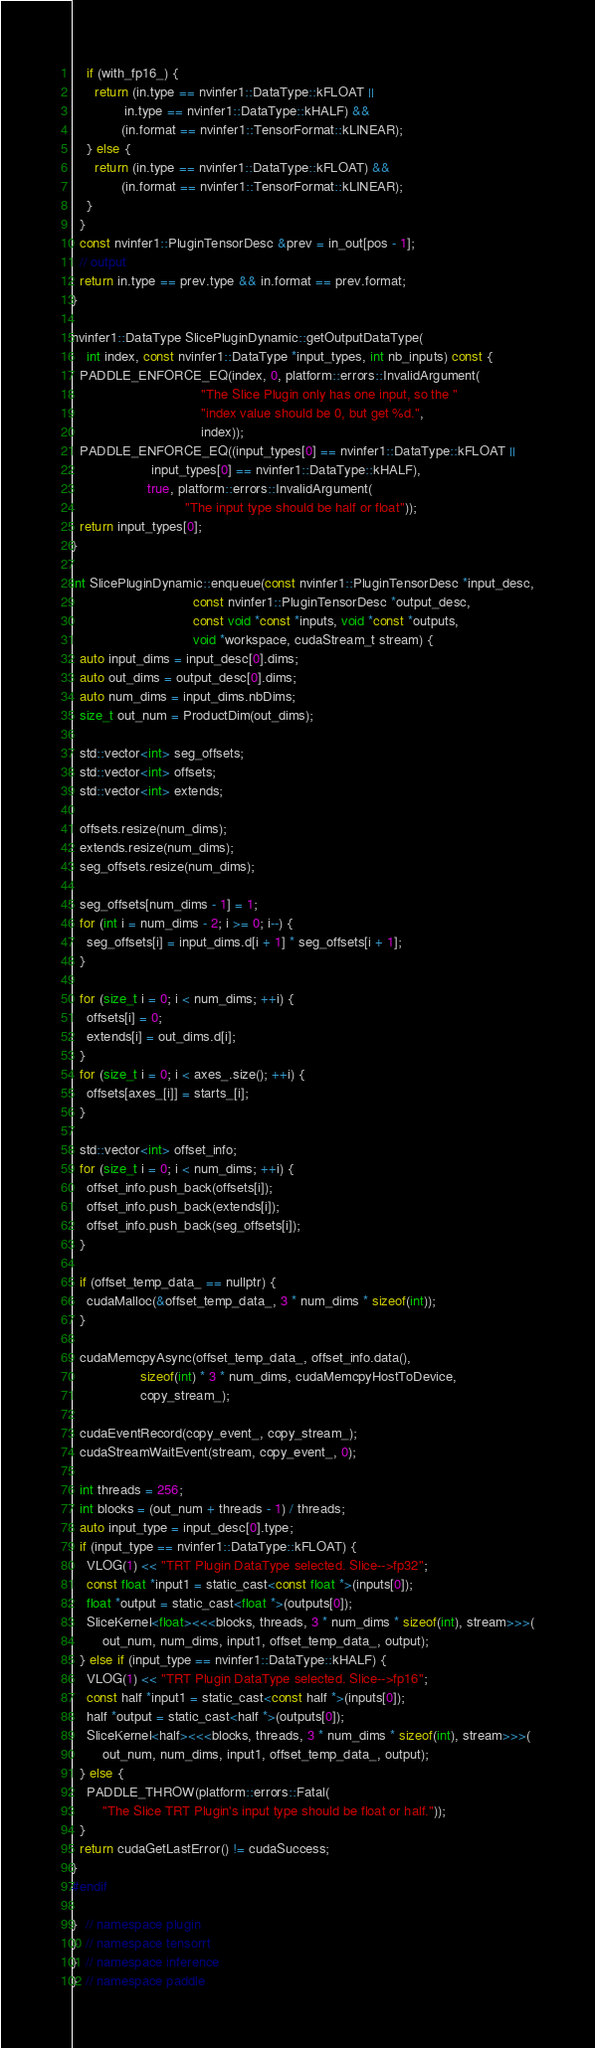Convert code to text. <code><loc_0><loc_0><loc_500><loc_500><_Cuda_>    if (with_fp16_) {
      return (in.type == nvinfer1::DataType::kFLOAT ||
              in.type == nvinfer1::DataType::kHALF) &&
             (in.format == nvinfer1::TensorFormat::kLINEAR);
    } else {
      return (in.type == nvinfer1::DataType::kFLOAT) &&
             (in.format == nvinfer1::TensorFormat::kLINEAR);
    }
  }
  const nvinfer1::PluginTensorDesc &prev = in_out[pos - 1];
  // output
  return in.type == prev.type && in.format == prev.format;
}

nvinfer1::DataType SlicePluginDynamic::getOutputDataType(
    int index, const nvinfer1::DataType *input_types, int nb_inputs) const {
  PADDLE_ENFORCE_EQ(index, 0, platform::errors::InvalidArgument(
                                  "The Slice Plugin only has one input, so the "
                                  "index value should be 0, but get %d.",
                                  index));
  PADDLE_ENFORCE_EQ((input_types[0] == nvinfer1::DataType::kFLOAT ||
                     input_types[0] == nvinfer1::DataType::kHALF),
                    true, platform::errors::InvalidArgument(
                              "The input type should be half or float"));
  return input_types[0];
}

int SlicePluginDynamic::enqueue(const nvinfer1::PluginTensorDesc *input_desc,
                                const nvinfer1::PluginTensorDesc *output_desc,
                                const void *const *inputs, void *const *outputs,
                                void *workspace, cudaStream_t stream) {
  auto input_dims = input_desc[0].dims;
  auto out_dims = output_desc[0].dims;
  auto num_dims = input_dims.nbDims;
  size_t out_num = ProductDim(out_dims);

  std::vector<int> seg_offsets;
  std::vector<int> offsets;
  std::vector<int> extends;

  offsets.resize(num_dims);
  extends.resize(num_dims);
  seg_offsets.resize(num_dims);

  seg_offsets[num_dims - 1] = 1;
  for (int i = num_dims - 2; i >= 0; i--) {
    seg_offsets[i] = input_dims.d[i + 1] * seg_offsets[i + 1];
  }

  for (size_t i = 0; i < num_dims; ++i) {
    offsets[i] = 0;
    extends[i] = out_dims.d[i];
  }
  for (size_t i = 0; i < axes_.size(); ++i) {
    offsets[axes_[i]] = starts_[i];
  }

  std::vector<int> offset_info;
  for (size_t i = 0; i < num_dims; ++i) {
    offset_info.push_back(offsets[i]);
    offset_info.push_back(extends[i]);
    offset_info.push_back(seg_offsets[i]);
  }

  if (offset_temp_data_ == nullptr) {
    cudaMalloc(&offset_temp_data_, 3 * num_dims * sizeof(int));
  }

  cudaMemcpyAsync(offset_temp_data_, offset_info.data(),
                  sizeof(int) * 3 * num_dims, cudaMemcpyHostToDevice,
                  copy_stream_);

  cudaEventRecord(copy_event_, copy_stream_);
  cudaStreamWaitEvent(stream, copy_event_, 0);

  int threads = 256;
  int blocks = (out_num + threads - 1) / threads;
  auto input_type = input_desc[0].type;
  if (input_type == nvinfer1::DataType::kFLOAT) {
    VLOG(1) << "TRT Plugin DataType selected. Slice-->fp32";
    const float *input1 = static_cast<const float *>(inputs[0]);
    float *output = static_cast<float *>(outputs[0]);
    SliceKernel<float><<<blocks, threads, 3 * num_dims * sizeof(int), stream>>>(
        out_num, num_dims, input1, offset_temp_data_, output);
  } else if (input_type == nvinfer1::DataType::kHALF) {
    VLOG(1) << "TRT Plugin DataType selected. Slice-->fp16";
    const half *input1 = static_cast<const half *>(inputs[0]);
    half *output = static_cast<half *>(outputs[0]);
    SliceKernel<half><<<blocks, threads, 3 * num_dims * sizeof(int), stream>>>(
        out_num, num_dims, input1, offset_temp_data_, output);
  } else {
    PADDLE_THROW(platform::errors::Fatal(
        "The Slice TRT Plugin's input type should be float or half."));
  }
  return cudaGetLastError() != cudaSuccess;
}
#endif

}  // namespace plugin
}  // namespace tensorrt
}  // namespace inference
}  // namespace paddle
</code> 